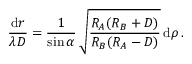Convert formula to latex. <formula><loc_0><loc_0><loc_500><loc_500>{ \frac { d \boldsymbol r } { \lambda D } } = { \frac { 1 } { \sin \alpha } } \, \sqrt { \frac { R _ { A } ( R _ { B } + D ) } { R _ { B } ( R _ { A } - D ) } } \, d \boldsymbol \rho \, .</formula> 